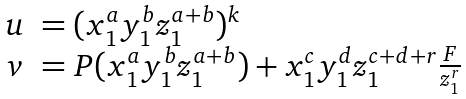<formula> <loc_0><loc_0><loc_500><loc_500>\begin{array} { l l } u & = ( x _ { 1 } ^ { a } y _ { 1 } ^ { b } z _ { 1 } ^ { a + b } ) ^ { k } \\ v & = P ( x _ { 1 } ^ { a } y _ { 1 } ^ { b } z _ { 1 } ^ { a + b } ) + x _ { 1 } ^ { c } y _ { 1 } ^ { d } z _ { 1 } ^ { c + d + r } \frac { F } { z _ { 1 } ^ { r } } \end{array}</formula> 